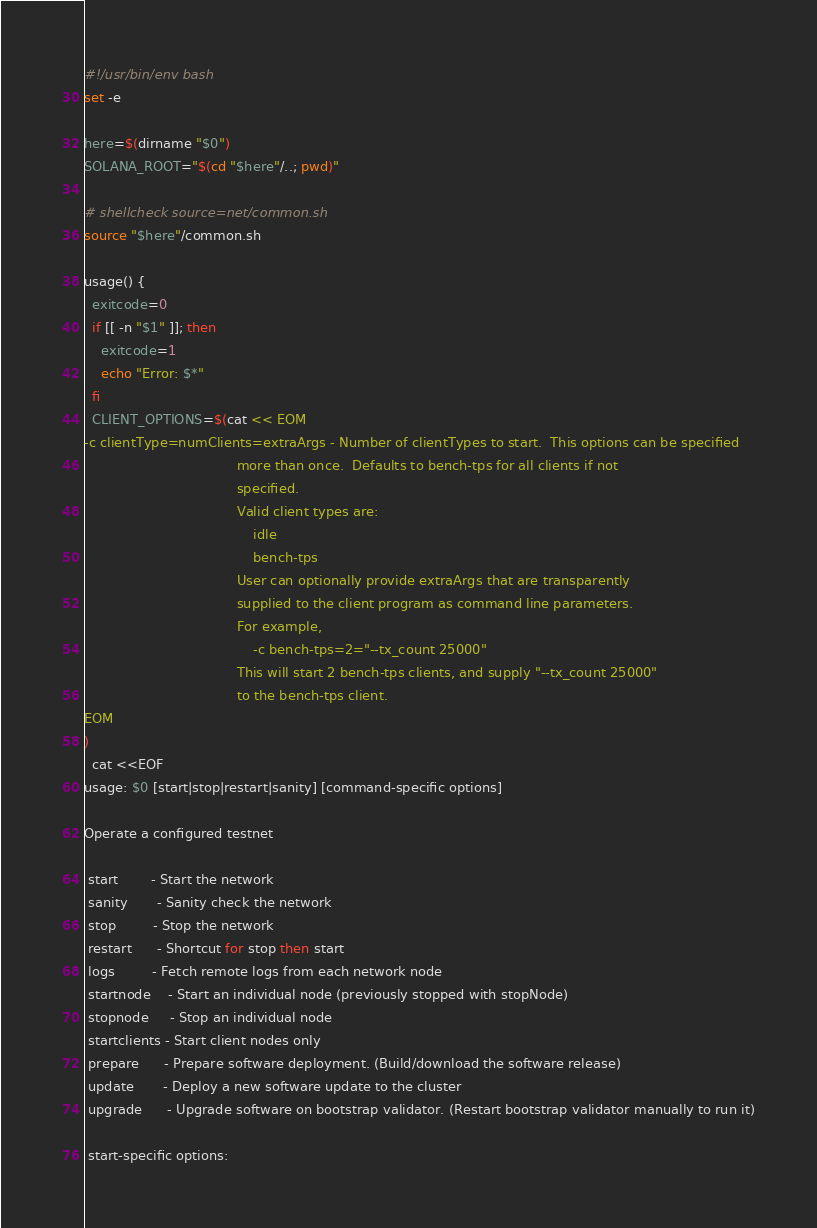Convert code to text. <code><loc_0><loc_0><loc_500><loc_500><_Bash_>#!/usr/bin/env bash
set -e

here=$(dirname "$0")
SOLANA_ROOT="$(cd "$here"/..; pwd)"

# shellcheck source=net/common.sh
source "$here"/common.sh

usage() {
  exitcode=0
  if [[ -n "$1" ]]; then
    exitcode=1
    echo "Error: $*"
  fi
  CLIENT_OPTIONS=$(cat << EOM
-c clientType=numClients=extraArgs - Number of clientTypes to start.  This options can be specified
                                     more than once.  Defaults to bench-tps for all clients if not
                                     specified.
                                     Valid client types are:
                                         idle
                                         bench-tps
                                     User can optionally provide extraArgs that are transparently
                                     supplied to the client program as command line parameters.
                                     For example,
                                         -c bench-tps=2="--tx_count 25000"
                                     This will start 2 bench-tps clients, and supply "--tx_count 25000"
                                     to the bench-tps client.
EOM
)
  cat <<EOF
usage: $0 [start|stop|restart|sanity] [command-specific options]

Operate a configured testnet

 start        - Start the network
 sanity       - Sanity check the network
 stop         - Stop the network
 restart      - Shortcut for stop then start
 logs         - Fetch remote logs from each network node
 startnode    - Start an individual node (previously stopped with stopNode)
 stopnode     - Stop an individual node
 startclients - Start client nodes only
 prepare      - Prepare software deployment. (Build/download the software release)
 update       - Deploy a new software update to the cluster
 upgrade      - Upgrade software on bootstrap validator. (Restart bootstrap validator manually to run it)

 start-specific options:</code> 